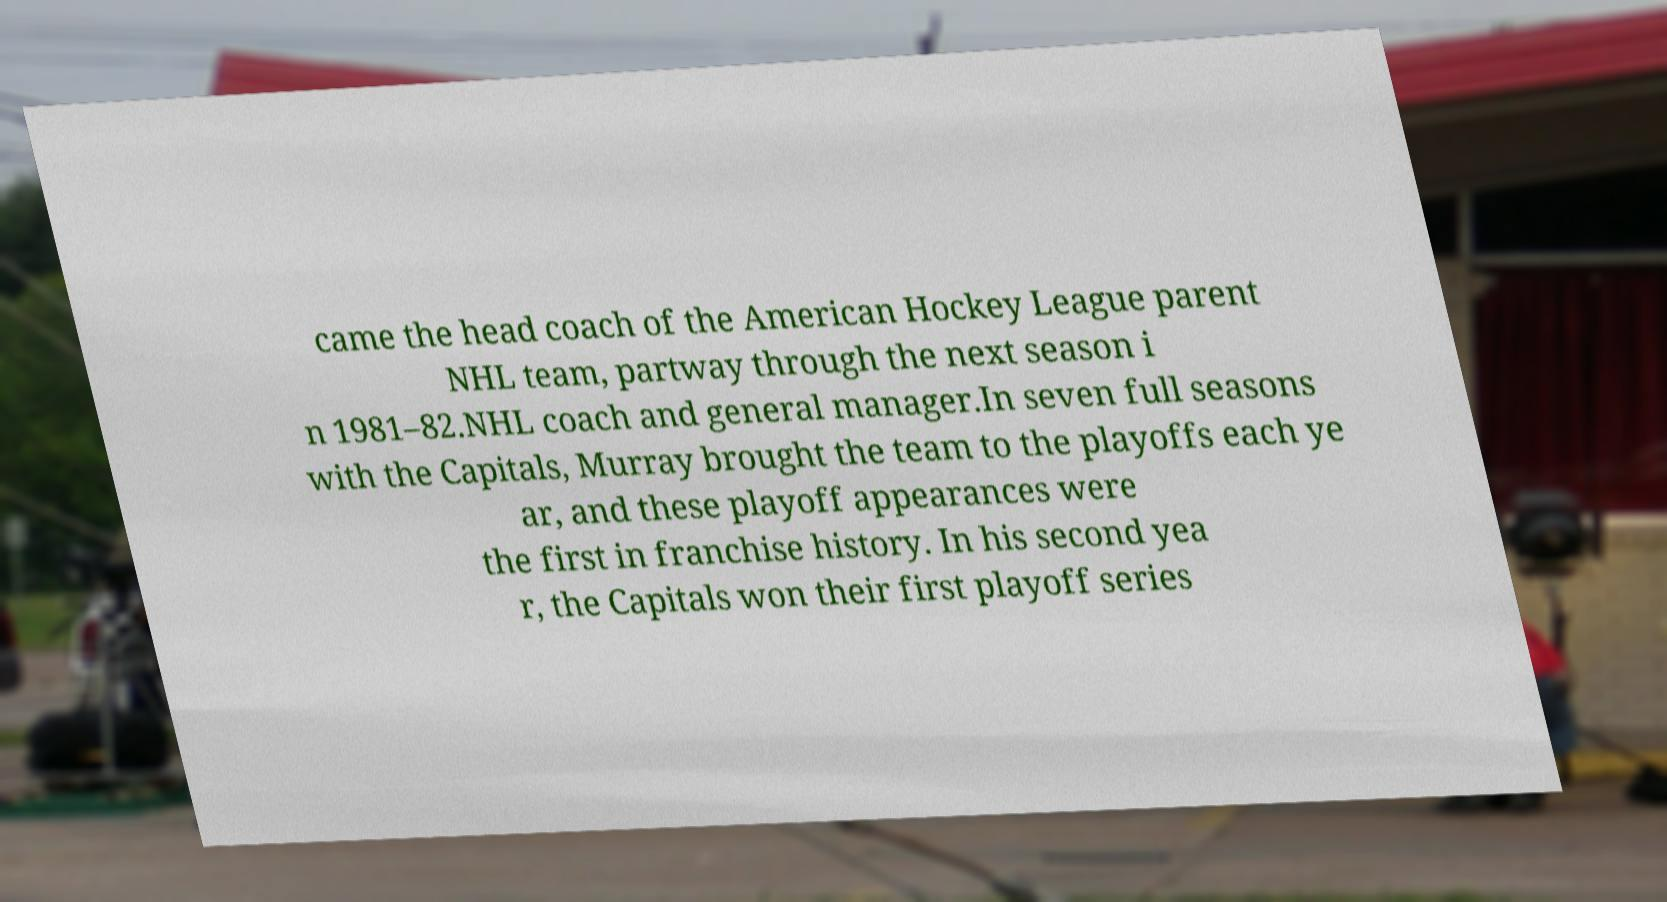Can you read and provide the text displayed in the image?This photo seems to have some interesting text. Can you extract and type it out for me? came the head coach of the American Hockey League parent NHL team, partway through the next season i n 1981–82.NHL coach and general manager.In seven full seasons with the Capitals, Murray brought the team to the playoffs each ye ar, and these playoff appearances were the first in franchise history. In his second yea r, the Capitals won their first playoff series 